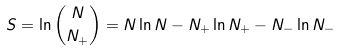Convert formula to latex. <formula><loc_0><loc_0><loc_500><loc_500>S = \ln { N \choose N _ { + } } = N \ln N - N _ { + } \ln N _ { + } - N _ { - } \ln N _ { - }</formula> 